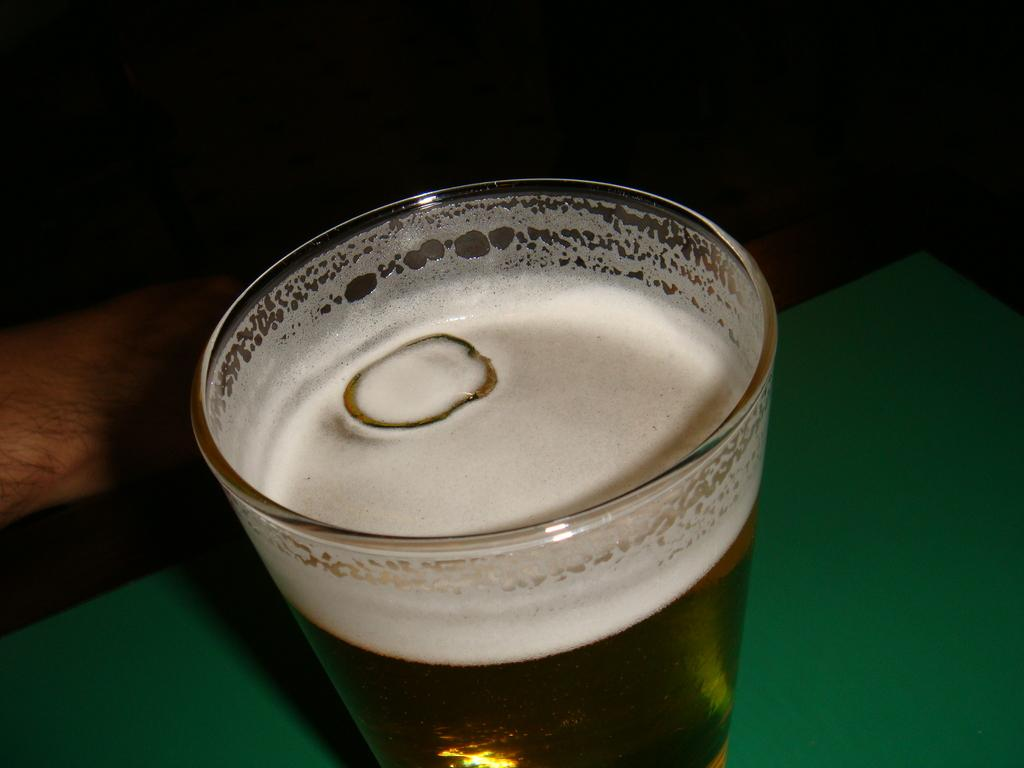What object is on the table in the image? There is a glass on a table in the image. Can you describe anything else visible on the table? Unfortunately, the provided facts do not mention any other objects on the table. What is located on the left side of the image? There is a human hand on the left side of the image. What type of lettuce is being held by the hand in the image? There is no lettuce present in the image; only a glass on a table and a human hand are visible. 